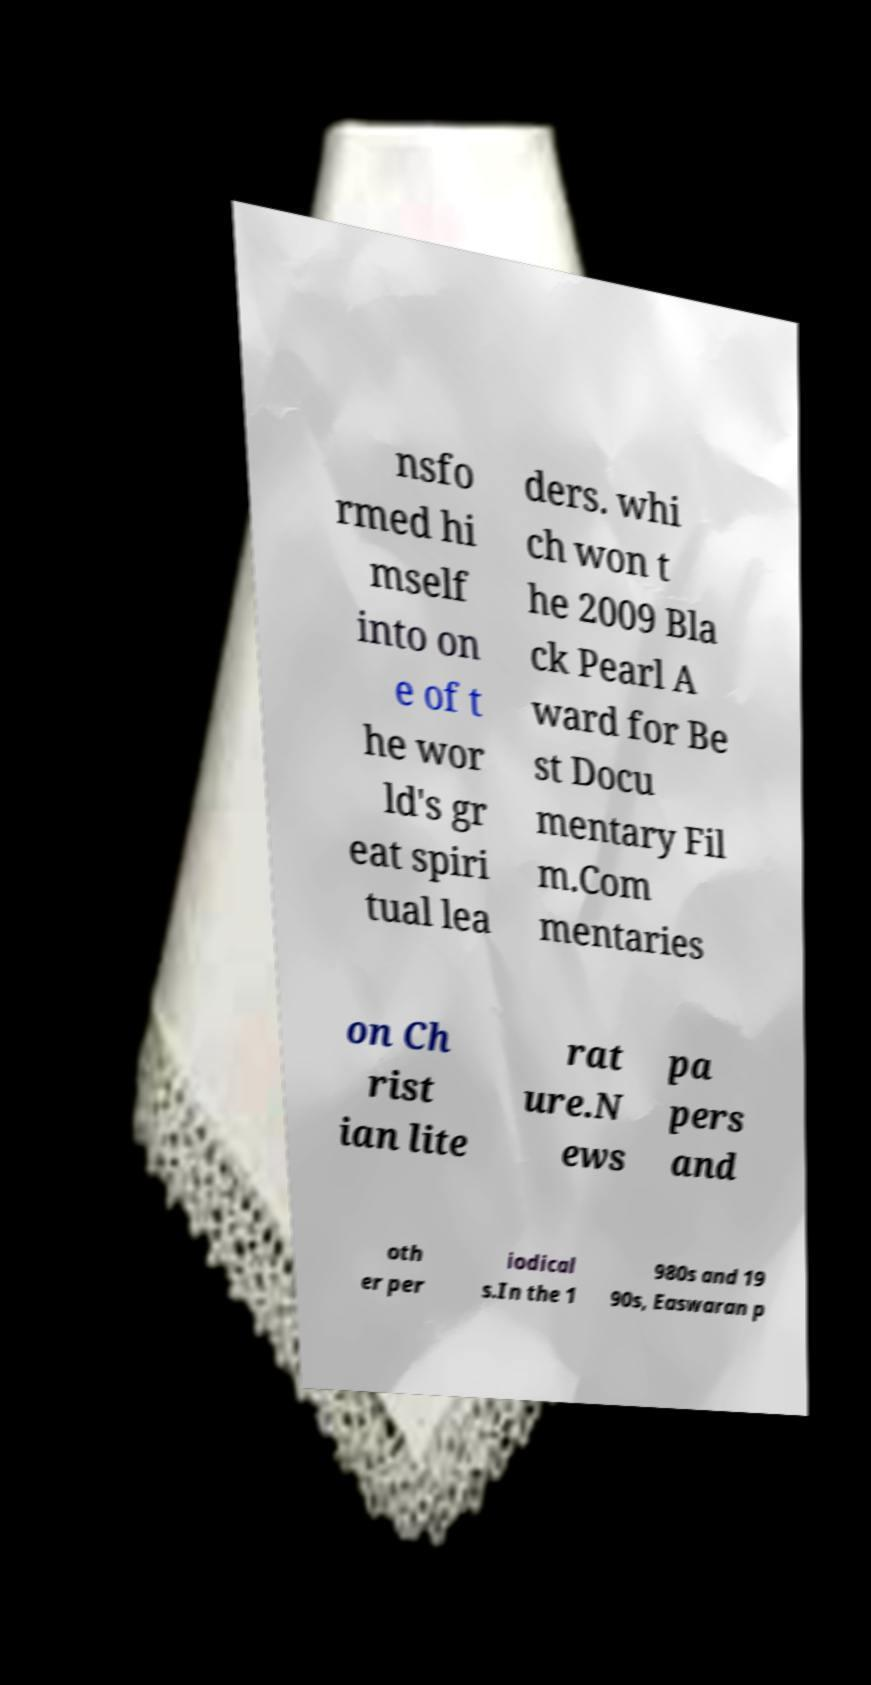I need the written content from this picture converted into text. Can you do that? nsfo rmed hi mself into on e of t he wor ld's gr eat spiri tual lea ders. whi ch won t he 2009 Bla ck Pearl A ward for Be st Docu mentary Fil m.Com mentaries on Ch rist ian lite rat ure.N ews pa pers and oth er per iodical s.In the 1 980s and 19 90s, Easwaran p 